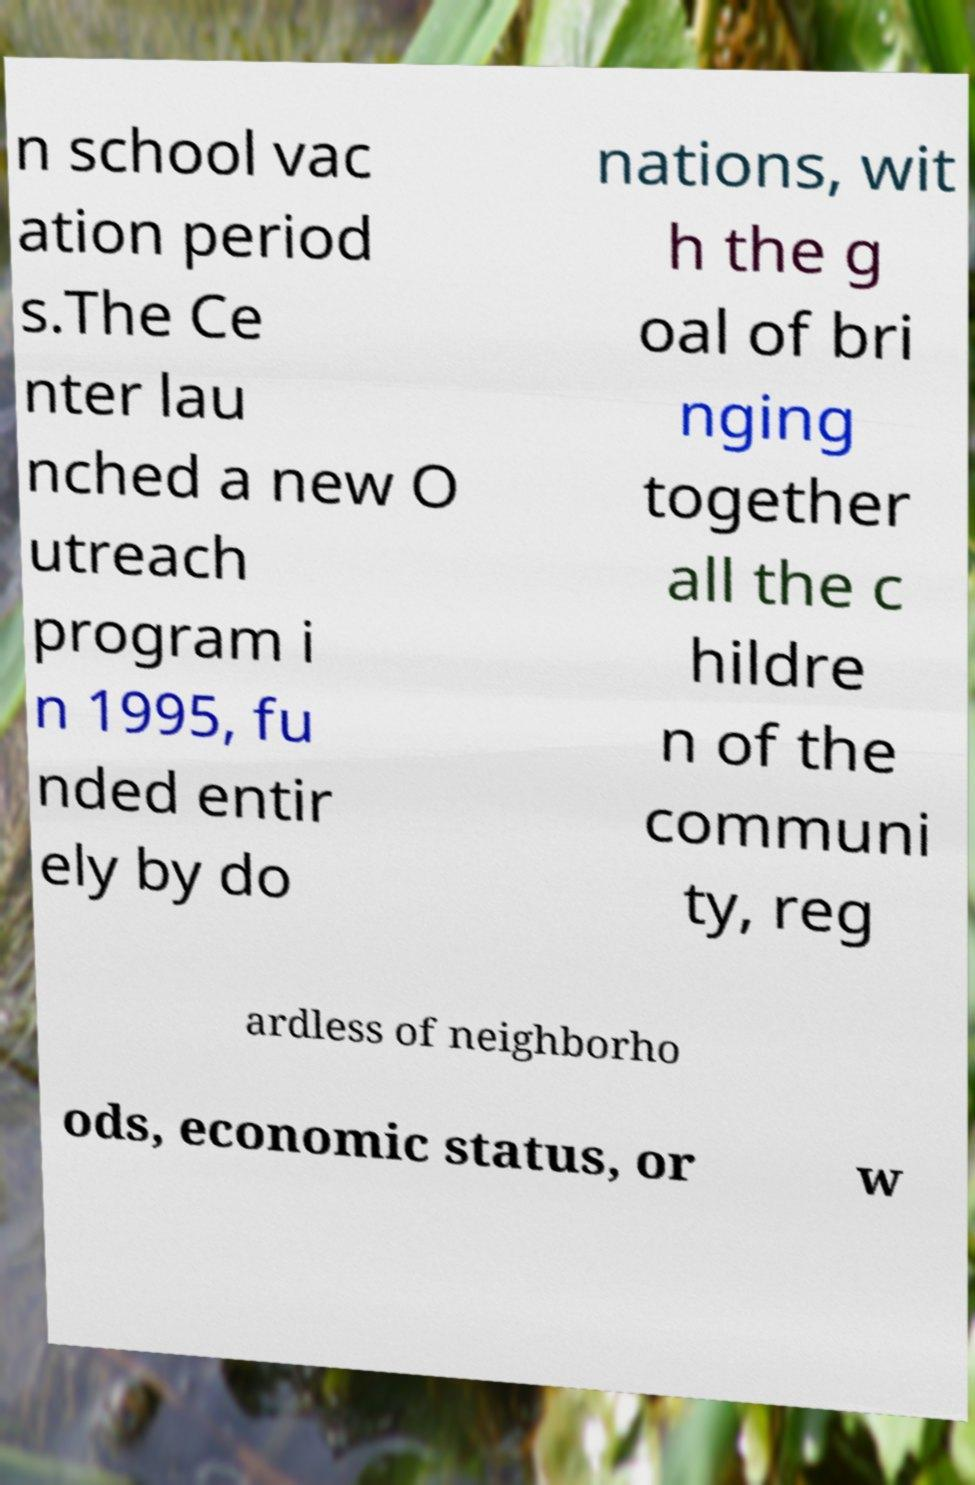I need the written content from this picture converted into text. Can you do that? n school vac ation period s.The Ce nter lau nched a new O utreach program i n 1995, fu nded entir ely by do nations, wit h the g oal of bri nging together all the c hildre n of the communi ty, reg ardless of neighborho ods, economic status, or w 